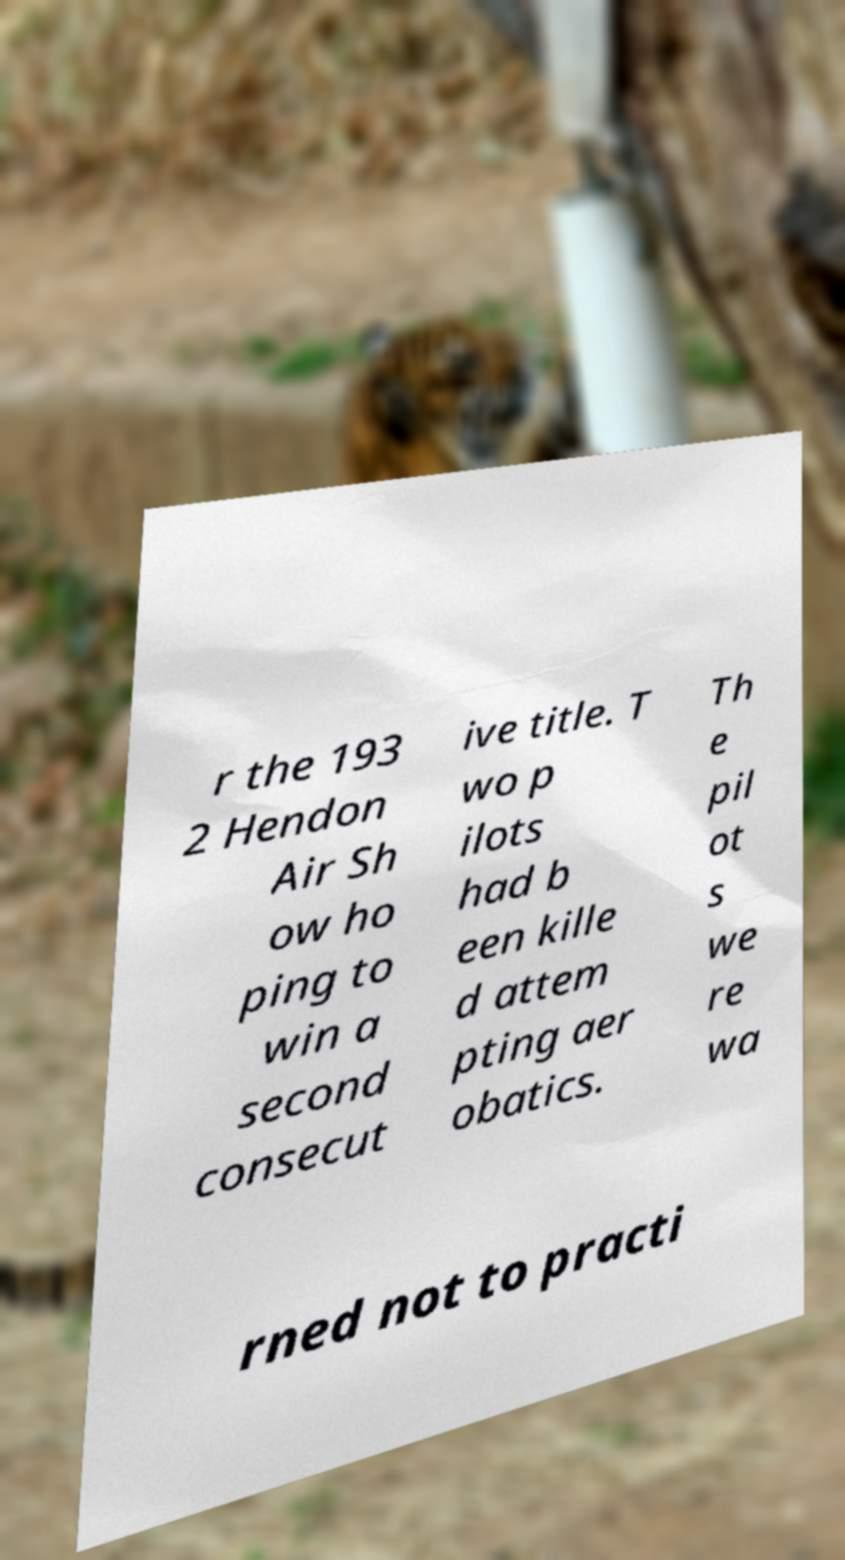I need the written content from this picture converted into text. Can you do that? r the 193 2 Hendon Air Sh ow ho ping to win a second consecut ive title. T wo p ilots had b een kille d attem pting aer obatics. Th e pil ot s we re wa rned not to practi 